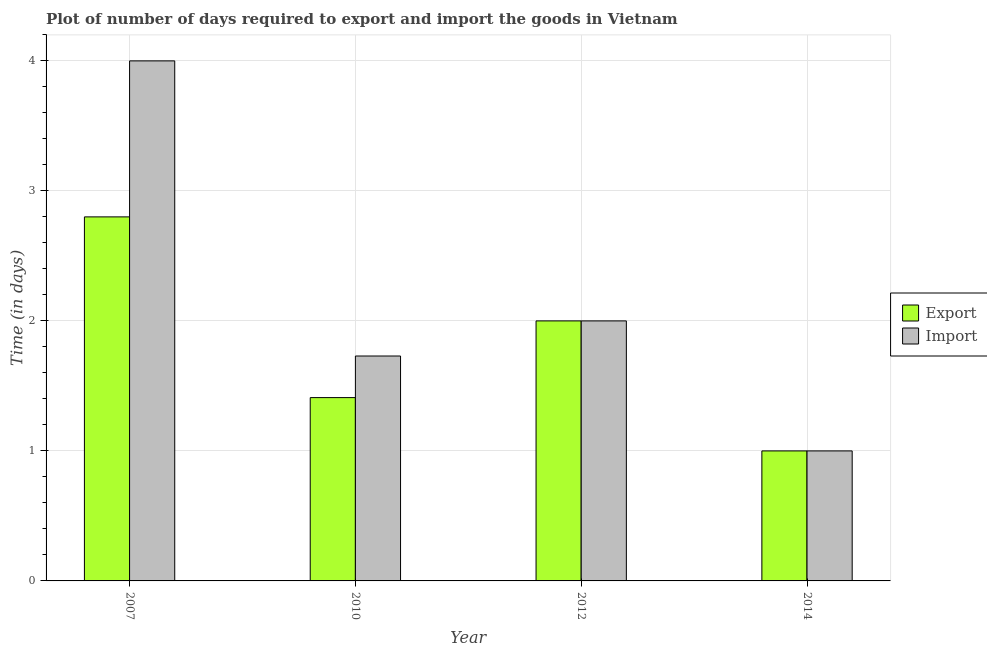How many different coloured bars are there?
Provide a short and direct response. 2. How many groups of bars are there?
Your response must be concise. 4. Are the number of bars on each tick of the X-axis equal?
Provide a succinct answer. Yes. How many bars are there on the 2nd tick from the left?
Your answer should be very brief. 2. What is the label of the 1st group of bars from the left?
Make the answer very short. 2007. In how many cases, is the number of bars for a given year not equal to the number of legend labels?
Give a very brief answer. 0. What is the time required to import in 2012?
Offer a very short reply. 2. In which year was the time required to import maximum?
Make the answer very short. 2007. In which year was the time required to export minimum?
Your answer should be compact. 2014. What is the total time required to import in the graph?
Give a very brief answer. 8.73. What is the difference between the time required to export in 2012 and the time required to import in 2010?
Offer a very short reply. 0.59. What is the average time required to import per year?
Provide a short and direct response. 2.18. In the year 2014, what is the difference between the time required to import and time required to export?
Give a very brief answer. 0. In how many years, is the time required to import greater than 1.2 days?
Keep it short and to the point. 3. What is the ratio of the time required to export in 2007 to that in 2010?
Offer a very short reply. 1.99. Is the difference between the time required to import in 2007 and 2012 greater than the difference between the time required to export in 2007 and 2012?
Offer a very short reply. No. What is the difference between the highest and the second highest time required to export?
Give a very brief answer. 0.8. What is the difference between the highest and the lowest time required to export?
Offer a terse response. 1.8. Is the sum of the time required to import in 2010 and 2012 greater than the maximum time required to export across all years?
Make the answer very short. No. What does the 2nd bar from the left in 2010 represents?
Your answer should be compact. Import. What does the 2nd bar from the right in 2007 represents?
Give a very brief answer. Export. How many years are there in the graph?
Give a very brief answer. 4. Are the values on the major ticks of Y-axis written in scientific E-notation?
Ensure brevity in your answer.  No. Does the graph contain grids?
Offer a terse response. Yes. What is the title of the graph?
Provide a short and direct response. Plot of number of days required to export and import the goods in Vietnam. Does "Working capital" appear as one of the legend labels in the graph?
Your response must be concise. No. What is the label or title of the X-axis?
Offer a terse response. Year. What is the label or title of the Y-axis?
Ensure brevity in your answer.  Time (in days). What is the Time (in days) in Export in 2010?
Your response must be concise. 1.41. What is the Time (in days) in Import in 2010?
Your answer should be very brief. 1.73. What is the Time (in days) of Export in 2012?
Offer a very short reply. 2. What is the Time (in days) in Import in 2012?
Keep it short and to the point. 2. Across all years, what is the minimum Time (in days) of Export?
Offer a very short reply. 1. Across all years, what is the minimum Time (in days) of Import?
Offer a very short reply. 1. What is the total Time (in days) in Export in the graph?
Give a very brief answer. 7.21. What is the total Time (in days) of Import in the graph?
Make the answer very short. 8.73. What is the difference between the Time (in days) of Export in 2007 and that in 2010?
Offer a terse response. 1.39. What is the difference between the Time (in days) of Import in 2007 and that in 2010?
Provide a short and direct response. 2.27. What is the difference between the Time (in days) in Export in 2007 and that in 2014?
Give a very brief answer. 1.8. What is the difference between the Time (in days) of Import in 2007 and that in 2014?
Keep it short and to the point. 3. What is the difference between the Time (in days) of Export in 2010 and that in 2012?
Provide a succinct answer. -0.59. What is the difference between the Time (in days) of Import in 2010 and that in 2012?
Provide a succinct answer. -0.27. What is the difference between the Time (in days) in Export in 2010 and that in 2014?
Make the answer very short. 0.41. What is the difference between the Time (in days) of Import in 2010 and that in 2014?
Offer a very short reply. 0.73. What is the difference between the Time (in days) of Export in 2012 and that in 2014?
Make the answer very short. 1. What is the difference between the Time (in days) in Export in 2007 and the Time (in days) in Import in 2010?
Keep it short and to the point. 1.07. What is the difference between the Time (in days) in Export in 2007 and the Time (in days) in Import in 2012?
Keep it short and to the point. 0.8. What is the difference between the Time (in days) of Export in 2007 and the Time (in days) of Import in 2014?
Make the answer very short. 1.8. What is the difference between the Time (in days) of Export in 2010 and the Time (in days) of Import in 2012?
Ensure brevity in your answer.  -0.59. What is the difference between the Time (in days) in Export in 2010 and the Time (in days) in Import in 2014?
Keep it short and to the point. 0.41. What is the average Time (in days) in Export per year?
Provide a short and direct response. 1.8. What is the average Time (in days) of Import per year?
Offer a very short reply. 2.18. In the year 2007, what is the difference between the Time (in days) in Export and Time (in days) in Import?
Make the answer very short. -1.2. In the year 2010, what is the difference between the Time (in days) in Export and Time (in days) in Import?
Offer a very short reply. -0.32. What is the ratio of the Time (in days) in Export in 2007 to that in 2010?
Offer a very short reply. 1.99. What is the ratio of the Time (in days) of Import in 2007 to that in 2010?
Provide a succinct answer. 2.31. What is the ratio of the Time (in days) in Import in 2007 to that in 2012?
Ensure brevity in your answer.  2. What is the ratio of the Time (in days) in Import in 2007 to that in 2014?
Your response must be concise. 4. What is the ratio of the Time (in days) of Export in 2010 to that in 2012?
Ensure brevity in your answer.  0.7. What is the ratio of the Time (in days) of Import in 2010 to that in 2012?
Offer a terse response. 0.86. What is the ratio of the Time (in days) in Export in 2010 to that in 2014?
Provide a short and direct response. 1.41. What is the ratio of the Time (in days) in Import in 2010 to that in 2014?
Provide a succinct answer. 1.73. What is the difference between the highest and the second highest Time (in days) of Import?
Your answer should be compact. 2. What is the difference between the highest and the lowest Time (in days) of Import?
Offer a terse response. 3. 